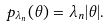Convert formula to latex. <formula><loc_0><loc_0><loc_500><loc_500>p _ { \lambda _ { n } } ( \theta ) = \lambda _ { n } | \theta | .</formula> 